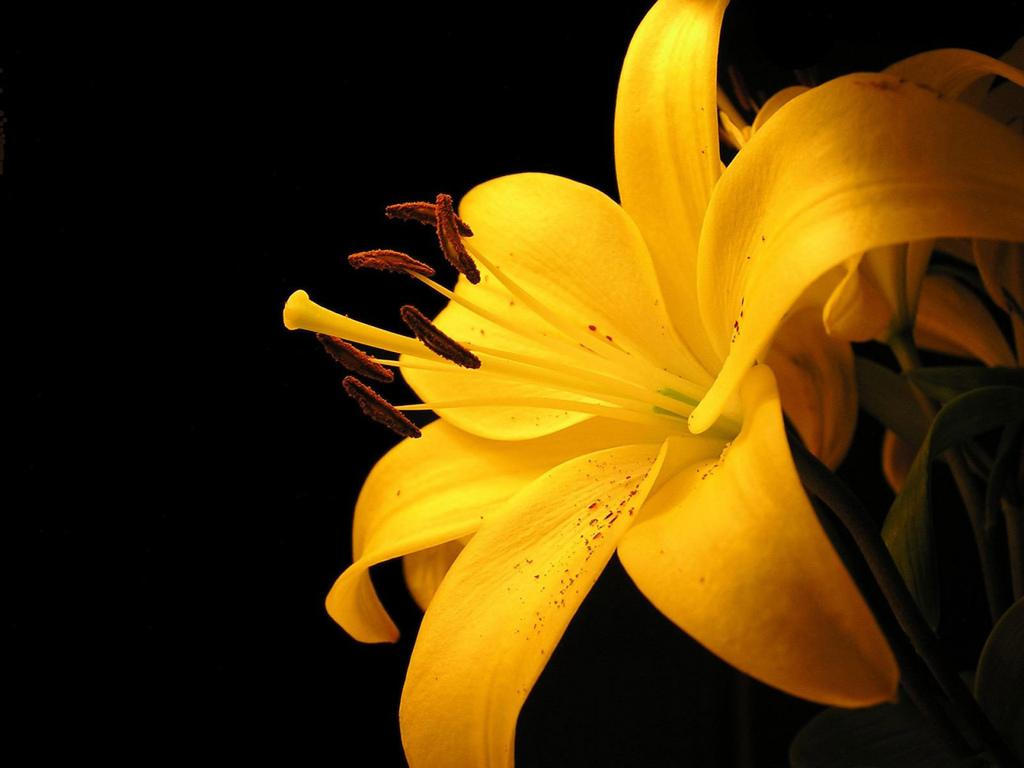What type of flower is present in the image? There is a yellow color flower in the image. What scientific experiment is being conducted with the flower in the image? There is no indication of a scientific experiment being conducted in the image; it simply shows a yellow color flower. 